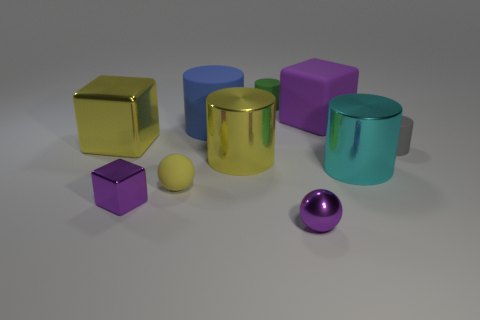How many purple cubes must be subtracted to get 1 purple cubes? 1 Subtract 2 cylinders. How many cylinders are left? 3 Subtract all purple cylinders. Subtract all yellow blocks. How many cylinders are left? 5 Subtract all balls. How many objects are left? 8 Subtract 0 brown balls. How many objects are left? 10 Subtract all large metallic objects. Subtract all blocks. How many objects are left? 4 Add 5 shiny things. How many shiny things are left? 10 Add 8 big blue rubber objects. How many big blue rubber objects exist? 9 